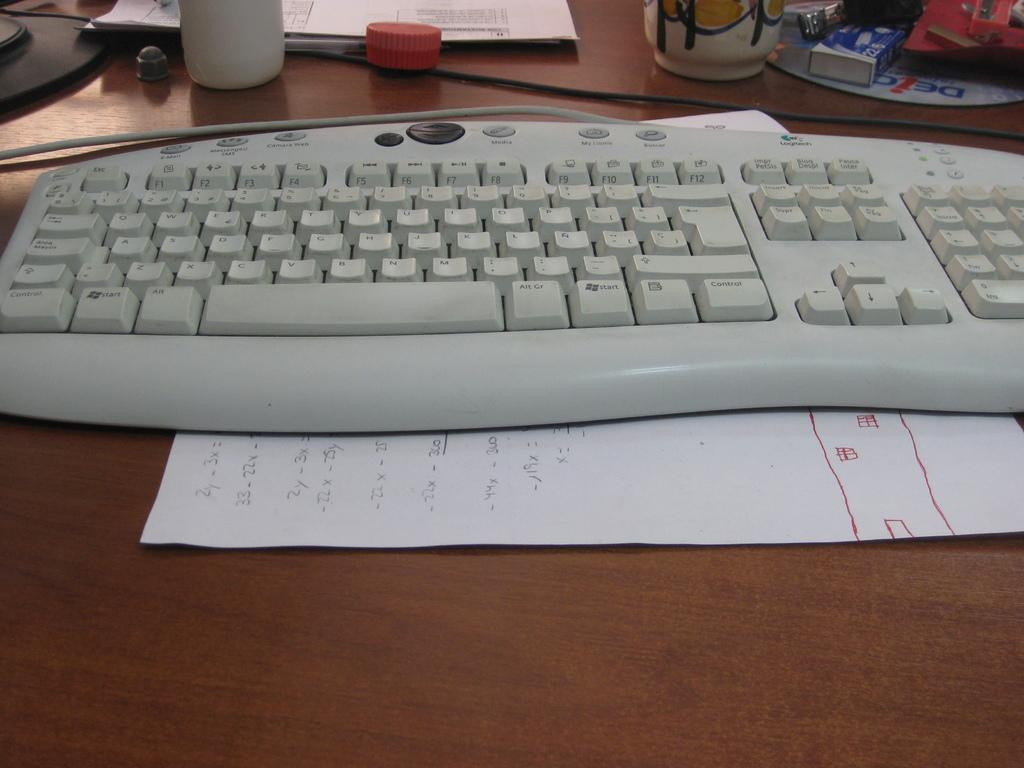What is the primary object visible in the image? There is a paper in the image. What device is also visible in the image? There is a keyboard in the image. What can be inferred about the setting of the image? The presence of a table suggests that the paper and keyboard are likely in an office or workspace setting. What other objects can be seen on the table in the image? There are other objects on the table in the image, but their specific details are not provided. How many snakes are slithering on the keyboard in the image? There are no snakes present in the image; the keyboard is not associated with any snakes. 